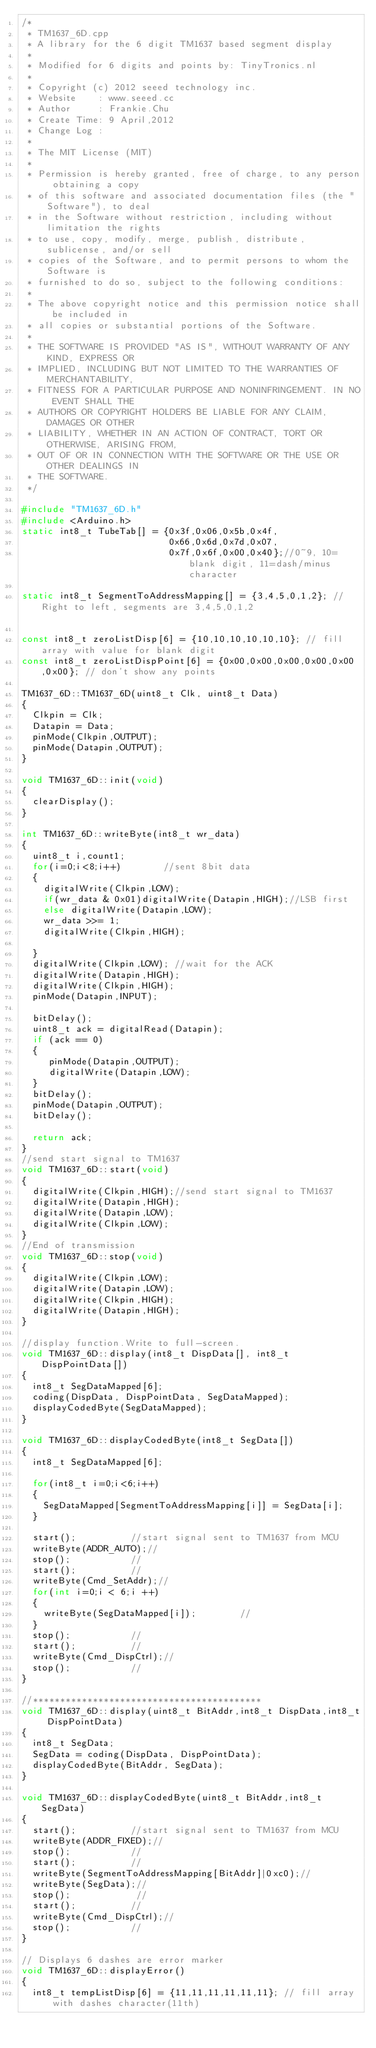Convert code to text. <code><loc_0><loc_0><loc_500><loc_500><_C++_>/*
 * TM1637_6D.cpp
 * A library for the 6 digit TM1637 based segment display
 *
 * Modified for 6 digits and points by: TinyTronics.nl
 *
 * Copyright (c) 2012 seeed technology inc.
 * Website    : www.seeed.cc
 * Author     : Frankie.Chu
 * Create Time: 9 April,2012
 * Change Log :
 *
 * The MIT License (MIT)
 *
 * Permission is hereby granted, free of charge, to any person obtaining a copy
 * of this software and associated documentation files (the "Software"), to deal
 * in the Software without restriction, including without limitation the rights
 * to use, copy, modify, merge, publish, distribute, sublicense, and/or sell
 * copies of the Software, and to permit persons to whom the Software is
 * furnished to do so, subject to the following conditions:
 *
 * The above copyright notice and this permission notice shall be included in
 * all copies or substantial portions of the Software.
 *
 * THE SOFTWARE IS PROVIDED "AS IS", WITHOUT WARRANTY OF ANY KIND, EXPRESS OR
 * IMPLIED, INCLUDING BUT NOT LIMITED TO THE WARRANTIES OF MERCHANTABILITY,
 * FITNESS FOR A PARTICULAR PURPOSE AND NONINFRINGEMENT. IN NO EVENT SHALL THE
 * AUTHORS OR COPYRIGHT HOLDERS BE LIABLE FOR ANY CLAIM, DAMAGES OR OTHER
 * LIABILITY, WHETHER IN AN ACTION OF CONTRACT, TORT OR OTHERWISE, ARISING FROM,
 * OUT OF OR IN CONNECTION WITH THE SOFTWARE OR THE USE OR OTHER DEALINGS IN
 * THE SOFTWARE.
 */

#include "TM1637_6D.h"
#include <Arduino.h>
static int8_t TubeTab[] = {0x3f,0x06,0x5b,0x4f,
                           0x66,0x6d,0x7d,0x07,
                           0x7f,0x6f,0x00,0x40};//0~9, 10=blank digit, 11=dash/minus character

static int8_t SegmentToAddressMapping[] = {3,4,5,0,1,2}; // Right to left, segments are 3,4,5,0,1,2						   

const int8_t zeroListDisp[6] = {10,10,10,10,10,10}; // fill array with value for blank digit
const int8_t zeroListDispPoint[6] = {0x00,0x00,0x00,0x00,0x00,0x00}; // don't show any points
  
TM1637_6D::TM1637_6D(uint8_t Clk, uint8_t Data)
{
  Clkpin = Clk;
  Datapin = Data;
  pinMode(Clkpin,OUTPUT);
  pinMode(Datapin,OUTPUT);
}

void TM1637_6D::init(void)
{
  clearDisplay();
}

int TM1637_6D::writeByte(int8_t wr_data)
{
  uint8_t i,count1;
  for(i=0;i<8;i++)        //sent 8bit data
  {
    digitalWrite(Clkpin,LOW);
    if(wr_data & 0x01)digitalWrite(Datapin,HIGH);//LSB first
    else digitalWrite(Datapin,LOW);
    wr_data >>= 1;
    digitalWrite(Clkpin,HIGH);

  }
  digitalWrite(Clkpin,LOW); //wait for the ACK
  digitalWrite(Datapin,HIGH);
  digitalWrite(Clkpin,HIGH);
  pinMode(Datapin,INPUT);

  bitDelay();
  uint8_t ack = digitalRead(Datapin);
  if (ack == 0) 
  {
     pinMode(Datapin,OUTPUT);
     digitalWrite(Datapin,LOW);
  }
  bitDelay();
  pinMode(Datapin,OUTPUT);
  bitDelay();
  
  return ack;
}
//send start signal to TM1637
void TM1637_6D::start(void)
{
  digitalWrite(Clkpin,HIGH);//send start signal to TM1637
  digitalWrite(Datapin,HIGH);
  digitalWrite(Datapin,LOW);
  digitalWrite(Clkpin,LOW);
}
//End of transmission
void TM1637_6D::stop(void)
{
  digitalWrite(Clkpin,LOW);
  digitalWrite(Datapin,LOW);
  digitalWrite(Clkpin,HIGH);
  digitalWrite(Datapin,HIGH);
}

//display function.Write to full-screen.
void TM1637_6D::display(int8_t DispData[], int8_t DispPointData[])
{
  int8_t SegDataMapped[6];
  coding(DispData, DispPointData, SegDataMapped);
  displayCodedByte(SegDataMapped);
}

void TM1637_6D::displayCodedByte(int8_t SegData[])
{
  int8_t SegDataMapped[6];

  for(int8_t i=0;i<6;i++)
  {
    SegDataMapped[SegmentToAddressMapping[i]] = SegData[i];
  } 
  
  start();          //start signal sent to TM1637 from MCU
  writeByte(ADDR_AUTO);//
  stop();           //
  start();          //
  writeByte(Cmd_SetAddr);//
  for(int i=0;i < 6;i ++)
  {
    writeByte(SegDataMapped[i]);        //
  }
  stop();           //
  start();          //
  writeByte(Cmd_DispCtrl);//
  stop();           //
}

//******************************************
void TM1637_6D::display(uint8_t BitAddr,int8_t DispData,int8_t DispPointData)
{
  int8_t SegData;
  SegData = coding(DispData, DispPointData);
  displayCodedByte(BitAddr, SegData);
}

void TM1637_6D::displayCodedByte(uint8_t BitAddr,int8_t SegData)
{
  start();          //start signal sent to TM1637 from MCU
  writeByte(ADDR_FIXED);//
  stop();           //
  start();          //
  writeByte(SegmentToAddressMapping[BitAddr]|0xc0);//
  writeByte(SegData);//
  stop();            //
  start();          //
  writeByte(Cmd_DispCtrl);//
  stop();           //
}

// Displays 6 dashes are error marker
void TM1637_6D::displayError()
{
  int8_t tempListDisp[6] = {11,11,11,11,11,11}; // fill array with dashes character(11th)</code> 